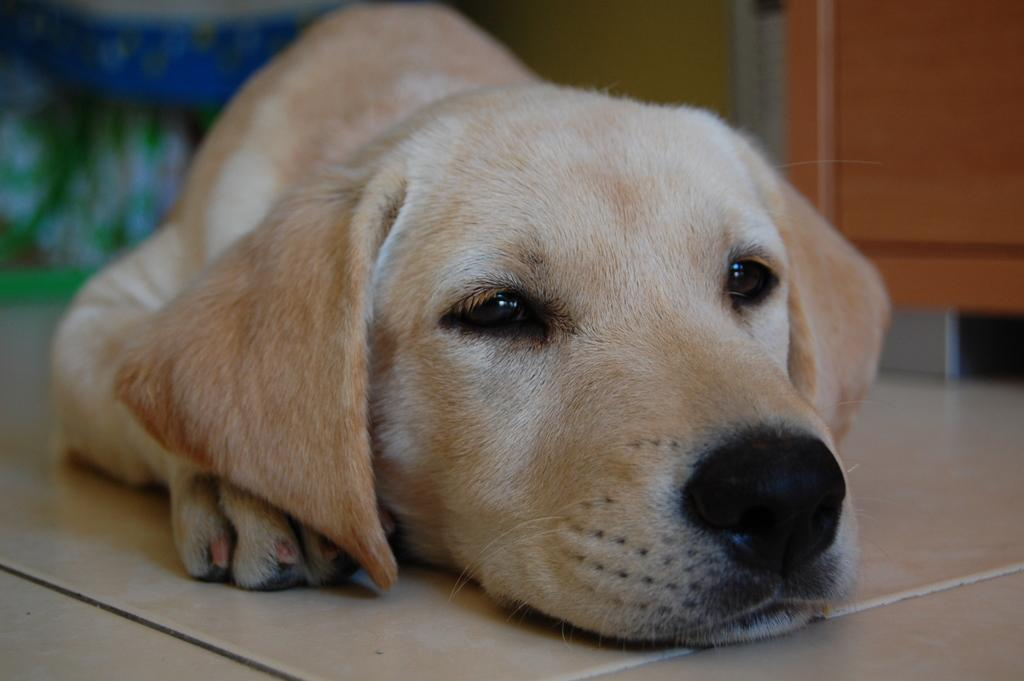What type of animal is in the image? There is a dog in the image. Can you describe the dog's appearance? The dog is cream-colored. How would you describe the quality of the image? The image is blurry in the background. What type of stocking is the dog wearing in the image? There is no stocking present on the dog in the image. How many cents can be seen in the image? There are no cents visible in the image. 